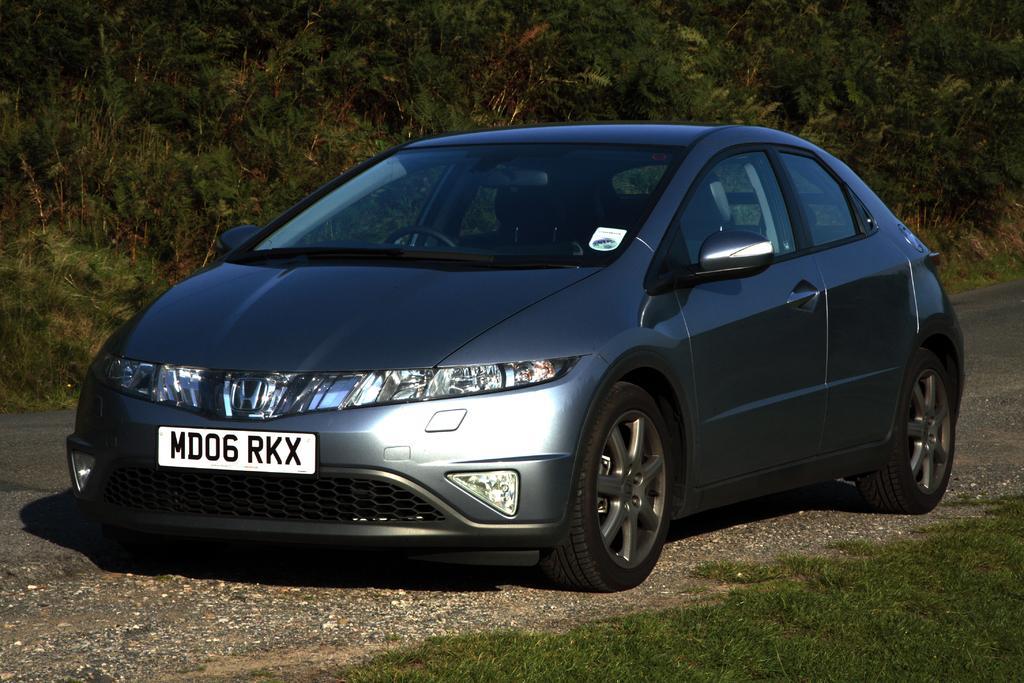Can you describe this image briefly? In this picture we can see a car, at the bottom there is grass, in the background we can see trees. 